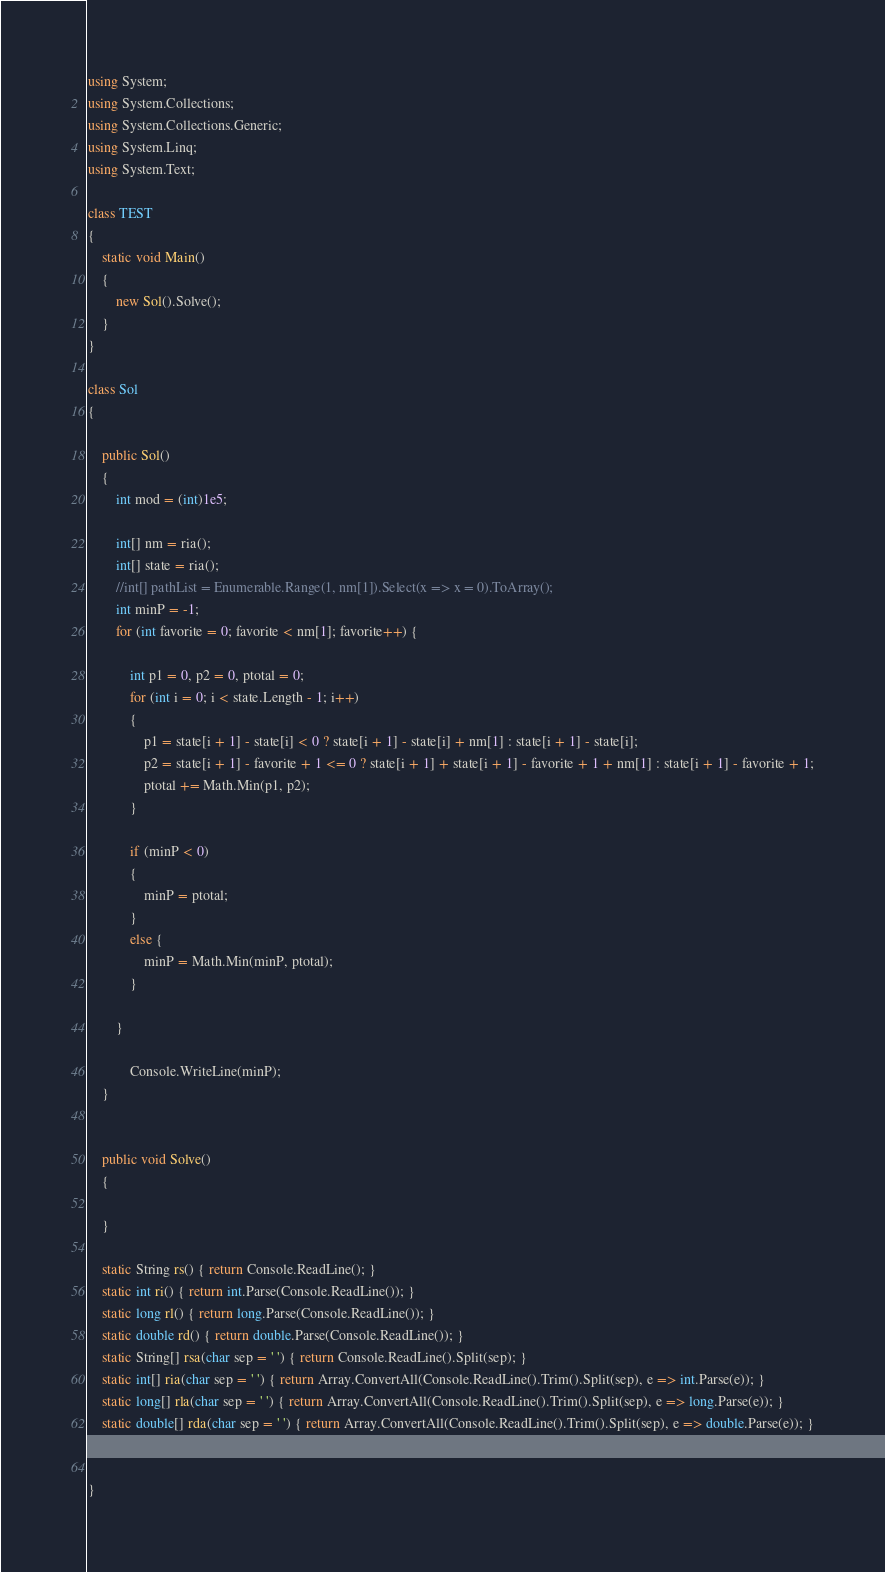Convert code to text. <code><loc_0><loc_0><loc_500><loc_500><_C#_>using System;
using System.Collections;
using System.Collections.Generic;
using System.Linq;
using System.Text;

class TEST
{
    static void Main()
    {
        new Sol().Solve();
    }
}

class Sol
{

    public Sol()
    {
        int mod = (int)1e5;

        int[] nm = ria();
        int[] state = ria();
        //int[] pathList = Enumerable.Range(1, nm[1]).Select(x => x = 0).ToArray();
        int minP = -1;
        for (int favorite = 0; favorite < nm[1]; favorite++) {

            int p1 = 0, p2 = 0, ptotal = 0;
            for (int i = 0; i < state.Length - 1; i++)
            {
                p1 = state[i + 1] - state[i] < 0 ? state[i + 1] - state[i] + nm[1] : state[i + 1] - state[i];
                p2 = state[i + 1] - favorite + 1 <= 0 ? state[i + 1] + state[i + 1] - favorite + 1 + nm[1] : state[i + 1] - favorite + 1;
                ptotal += Math.Min(p1, p2);
            }

            if (minP < 0)
            {
                minP = ptotal;
            }
            else {
                minP = Math.Min(minP, ptotal);
            }

        }

            Console.WriteLine(minP);
    }


    public void Solve()
    {

    }

    static String rs() { return Console.ReadLine(); }
    static int ri() { return int.Parse(Console.ReadLine()); }
    static long rl() { return long.Parse(Console.ReadLine()); }
    static double rd() { return double.Parse(Console.ReadLine()); }
    static String[] rsa(char sep = ' ') { return Console.ReadLine().Split(sep); }
    static int[] ria(char sep = ' ') { return Array.ConvertAll(Console.ReadLine().Trim().Split(sep), e => int.Parse(e)); }
    static long[] rla(char sep = ' ') { return Array.ConvertAll(Console.ReadLine().Trim().Split(sep), e => long.Parse(e)); }
    static double[] rda(char sep = ' ') { return Array.ConvertAll(Console.ReadLine().Trim().Split(sep), e => double.Parse(e)); }


}</code> 